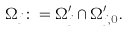<formula> <loc_0><loc_0><loc_500><loc_500>\Omega _ { j } \colon = \Omega _ { j } ^ { \prime } \cap \Omega _ { j , 0 } ^ { \prime } .</formula> 